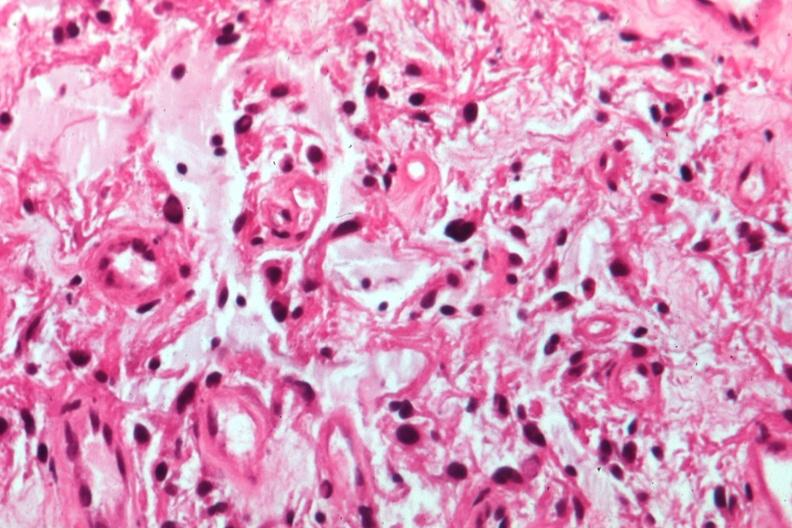s optic nerve present?
Answer the question using a single word or phrase. Yes 